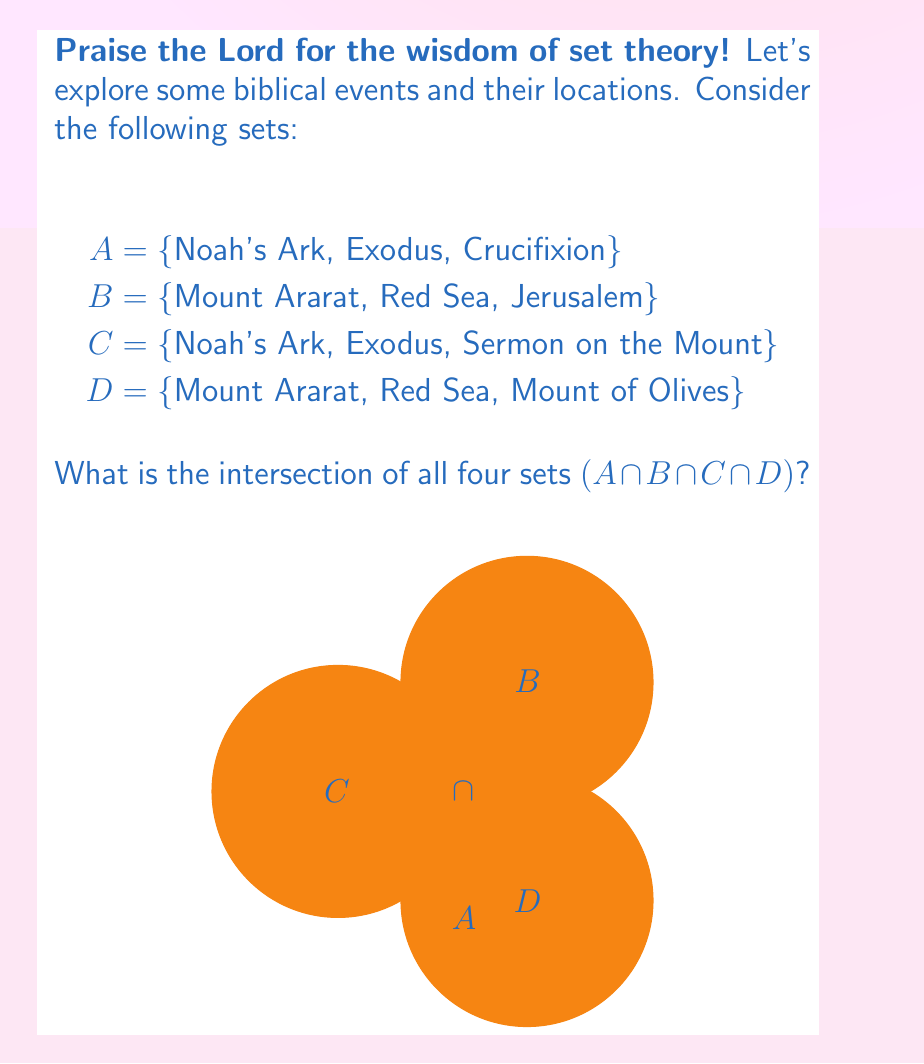What is the answer to this math problem? Let's approach this step-by-step, as guided by the Holy Spirit:

1) First, we need to understand what intersection means. The intersection of sets includes only the elements that are present in all the sets being considered.

2) Let's examine each set:
   A = {Noah's Ark, Exodus, Crucifixion}
   B = {Mount Ararat, Red Sea, Jerusalem}
   C = {Noah's Ark, Exodus, Sermon on the Mount}
   D = {Mount Ararat, Red Sea, Mount of Olives}

3) To find A ∩ B ∩ C ∩ D, we need to identify elements that appear in all four sets.

4) Comparing A and C:
   - They both contain Noah's Ark and Exodus
   - But these are events, not locations

5) Comparing B and D:
   - They both contain Mount Ararat and Red Sea
   - But these are locations, not events

6) When we consider all four sets together, we see that there is no single element that appears in all of them.

7) Therefore, the intersection of all four sets is the empty set, denoted as ∅ or {}.

8) In set theory notation, we write this as:
   $A ∩ B ∩ C ∩ D = ∅$

Just as the Bible teaches us that narrow is the way that leads to life (Matthew 7:14), we see here that the intersection of these sets is indeed narrow - it's empty!
Answer: $∅$ 